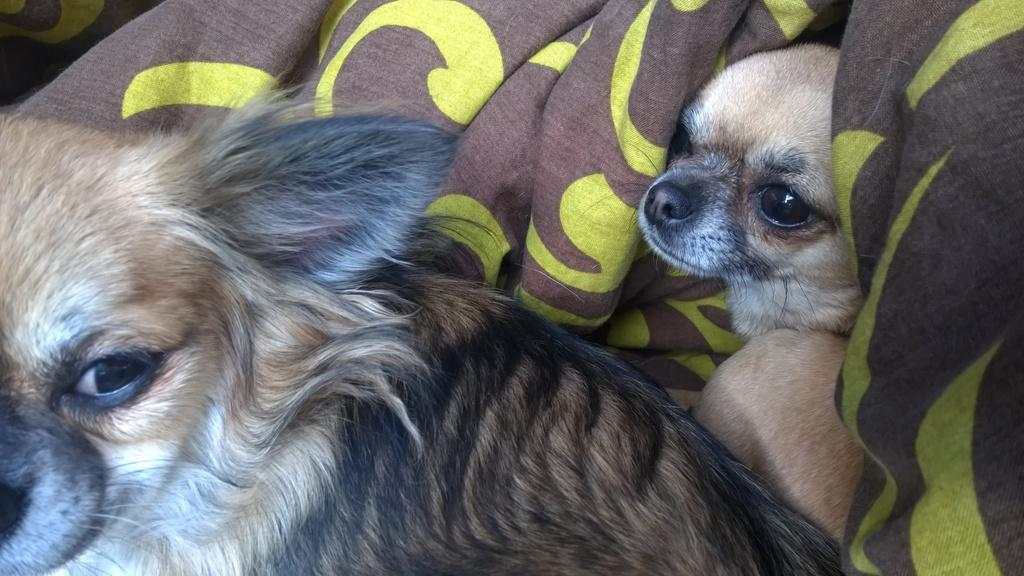How many puppies are present in the image? There are two puppies in the image. What is the color of the puppies? The puppies are brown in color. How are the puppies positioned in the image? The puppies are wrapped in a blanket. What colors are present in the blanket? The blanket is brown and yellow in color. What time of day is it in the image, based on the hour? The provided facts do not mention the time of day or any hour, so it cannot be determined from the image. --- Facts: 1. There is a bicycle in the image. 2. The bicycle has two wheels. 3. The bicycle has a basket attached to the front. 4. There is a person riding the bicycle. 5. The person is wearing a helmet. Absurd Topics: parrot, volcano, piano Conversation: What is the main object in the image? There is a bicycle in the image. How many wheels does the bicycle have? The bicycle has two wheels. What additional feature is attached to the bicycle? There is a basket attached to the front of the bicycle. Who is riding the bicycle in the image? There is a person riding the bicycle in the image. What safety precaution is the person taking while riding the bicycle? The person is wearing a helmet. Reasoning: Let's think step by step in order to produce the conversation. We start by identifying the main object in the image, which is the bicycle. Then, we describe the bicycle's features, such as the number of wheels and the presence of a basket. Next, we mention the person riding the bicycle and their safety precaution, which is wearing a helmet. Absurd Question/Answer: Can you see a parrot sitting on the handlebars of the bicycle in the image? No, there is no parrot present in the image. 